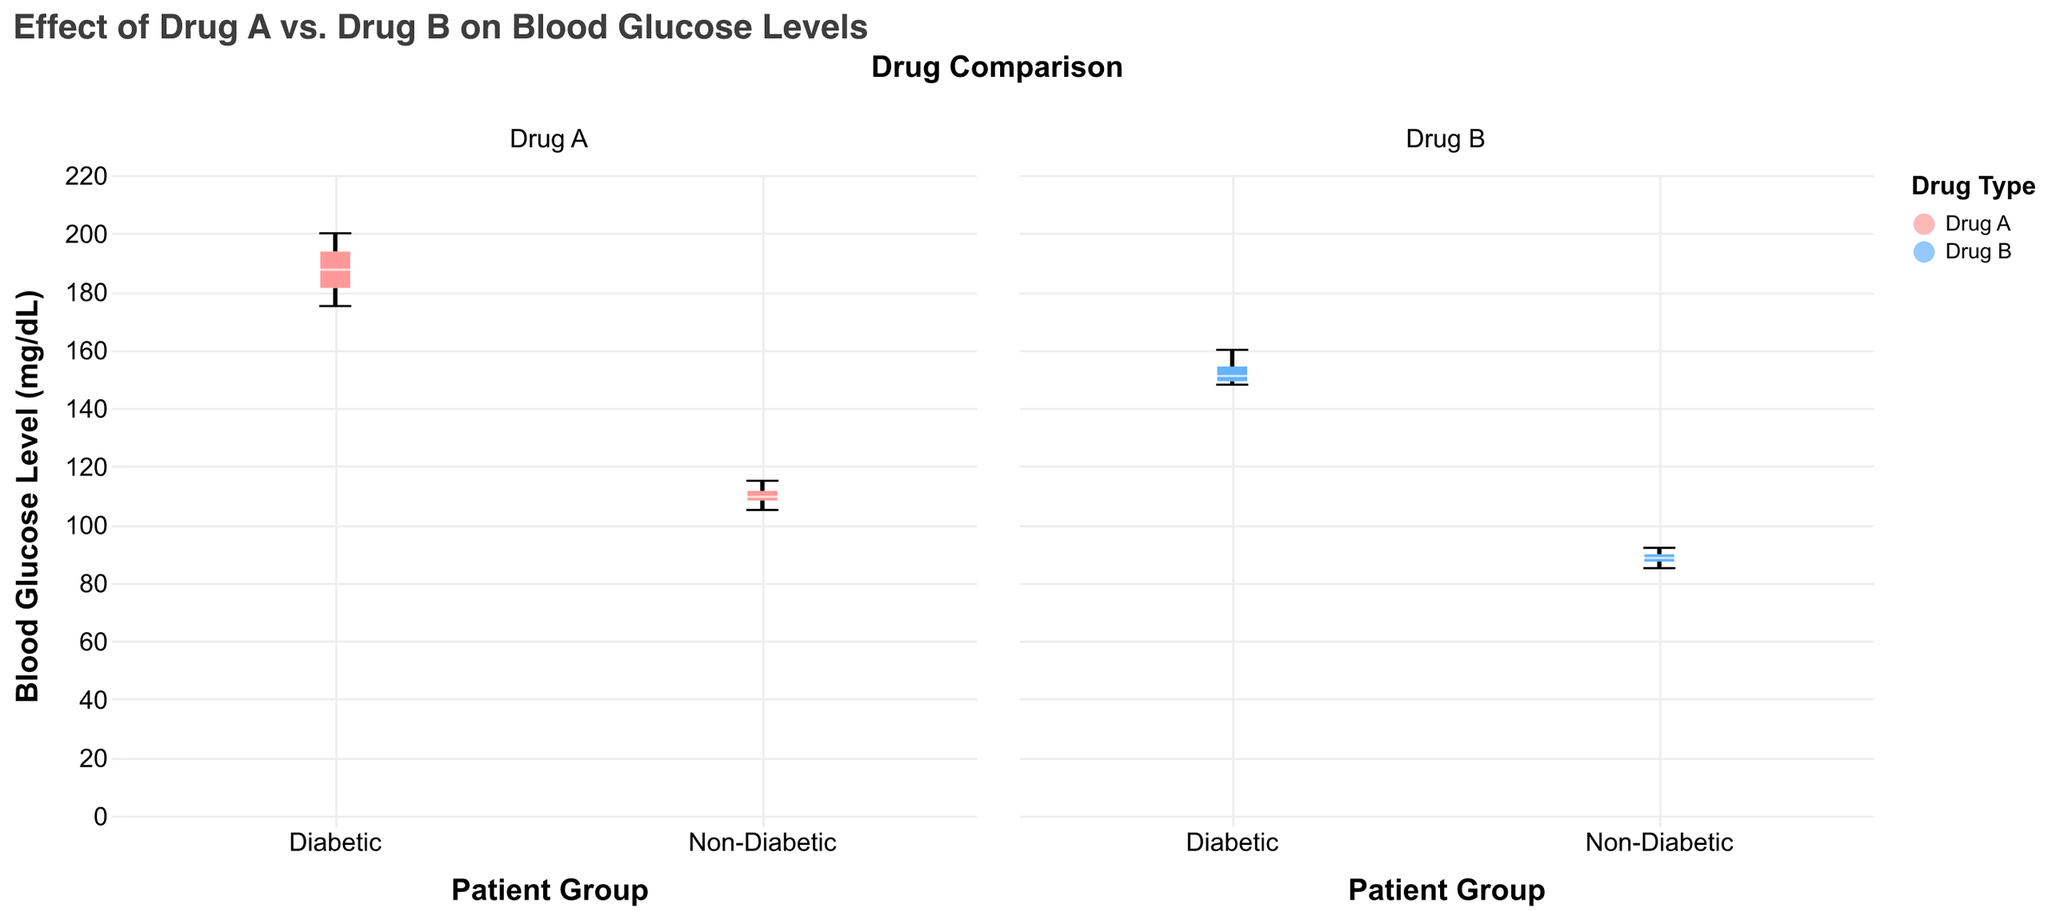What is the title of the figure? The title of the figure is shown at the top and states "Effect of Drug A vs. Drug B on Blood Glucose Levels".
Answer: "Effect of Drug A vs. Drug B on Blood Glucose Levels" How many groups are being compared in the figure? The figure compares two groups based on "Diabetic Status": Diabetic and Non-Diabetic.
Answer: Two What is the range of Blood Glucose Levels for Diabetic patients taking Drug A? For Diabetic patients taking Drug A, the box plot whiskers indicate the minimum and maximum values. These values are approximately 175 mg/dL to 200 mg/dL.
Answer: 175 - 200 mg/dL Which drug shows a lower median Blood Glucose Level for Diabetic patients? By comparing the medians in the box plots for Diabetic patients, Drug B shows a lower median than Drug A.
Answer: Drug B What is the median Blood Glucose Level for Non-Diabetic patients taking Drug B? From the box plot for Non-Diabetic patients taking Drug B, the median Blood Glucose Level is indicated by the line inside the box. It is approximately 89 mg/dL.
Answer: 89 mg/dL How does the interquartile range (IQR) compare for Non-Diabetic patients between Drug A and Drug B? The IQR is the difference between the first and third quartiles. Non-Diabetic patients taking Drug A have an IQR of about 105 to 112 mg/dL (7 mg/dL), while those taking Drug B have an IQR of about 87 to 90 mg/dL (3 mg/dL).
Answer: Drug A: 7 mg/dL, Drug B: 3 mg/dL Which group has the highest overall Blood Glucose Level observed, and what is that value? The highest overall Blood Glucose Level can be seen in the box plot for Diabetic patients taking Drug A, showing a value of approximately 200 mg/dL.
Answer: Diabetic, Drug A: 200 mg/dL Is there any overlap in the Blood Glucose Levels between Diabetic and Non-Diabetic patients taking Drug B? To determine overlap, compare the minimum and maximum values of the respective box plots. Diabetic patients taking Drug B have values from around 148 to 160 mg/dL, and Non-Diabetic patients taking Drug B have values from around 85 to 92 mg/dL. There is no overlap.
Answer: No What can you infer about the effectiveness of Drug B compared to Drug A in lowering Blood Glucose Levels in Diabetic patients? Drug B shows consistently lower Blood Glucose Levels and a lower median compared to Drug A for Diabetic patients, suggesting it's more effective in lowering glucose levels for this group.
Answer: Drug B is more effective Which patient group and drug combination exhibits the narrowest range of Blood Glucose Levels? By examining the width of the box plot whiskers, Non-Diabetic patients taking Drug B have the narrowest range, from about 85 to 92 mg/dL (7 mg/dL).
Answer: Non-Diabetic, Drug B 